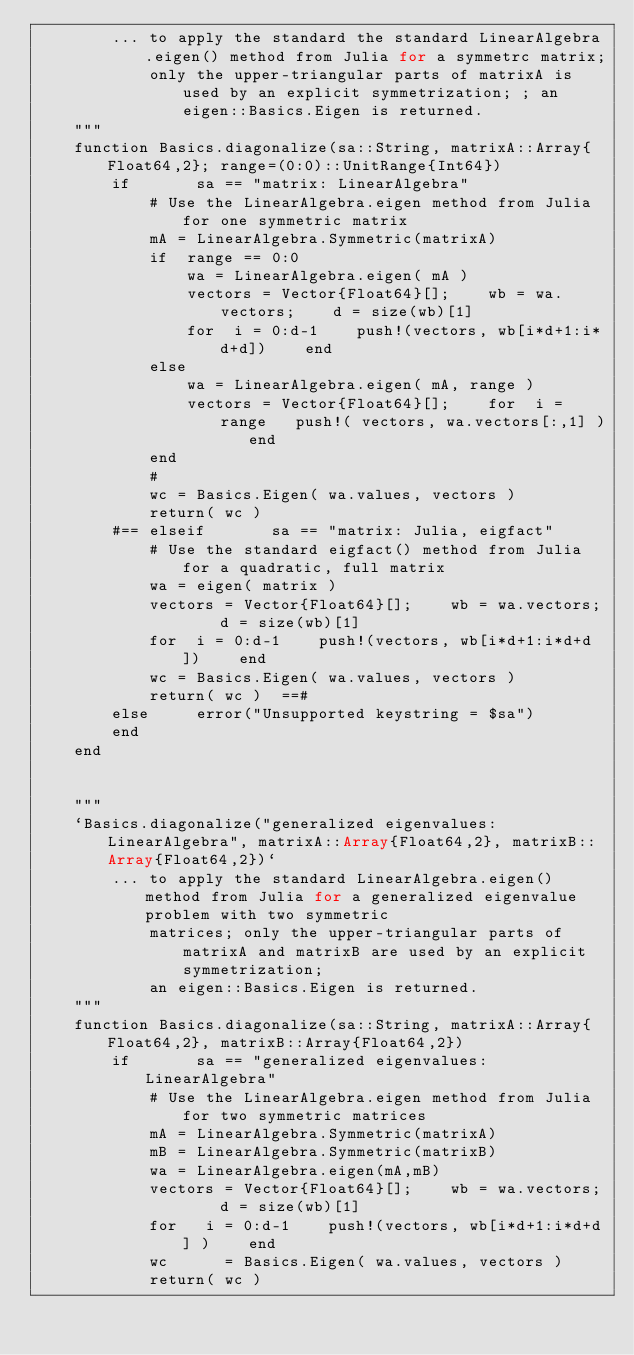<code> <loc_0><loc_0><loc_500><loc_500><_Julia_>        ... to apply the standard the standard LinearAlgebra.eigen() method from Julia for a symmetrc matrix; 
            only the upper-triangular parts of matrixA is used by an explicit symmetrization; ; an eigen::Basics.Eigen is returned.
    """
    function Basics.diagonalize(sa::String, matrixA::Array{Float64,2}; range=(0:0)::UnitRange{Int64})
        if       sa == "matrix: LinearAlgebra" 
            # Use the LinearAlgebra.eigen method from Julia for one symmetric matrix  
            mA = LinearAlgebra.Symmetric(matrixA)
            if  range == 0:0    
                wa = LinearAlgebra.eigen( mA )
                vectors = Vector{Float64}[];    wb = wa.vectors;    d = size(wb)[1]
                for  i = 0:d-1    push!(vectors, wb[i*d+1:i*d+d])    end
            else                
                wa = LinearAlgebra.eigen( mA, range )
                vectors = Vector{Float64}[];    for  i = range   push!( vectors, wa.vectors[:,1] )   end
            end
            #
            wc = Basics.Eigen( wa.values, vectors )
            return( wc )
        #== elseif       sa == "matrix: Julia, eigfact" 
            # Use the standard eigfact() method from Julia for a quadratic, full matrix   
            wa = eigen( matrix )
            vectors = Vector{Float64}[];    wb = wa.vectors;    d = size(wb)[1]
            for  i = 0:d-1    push!(vectors, wb[i*d+1:i*d+d])    end
            wc = Basics.Eigen( wa.values, vectors )
            return( wc )  ==#
        else     error("Unsupported keystring = $sa")
        end
    end


    """
    `Basics.diagonalize("generalized eigenvalues: LinearAlgebra", matrixA::Array{Float64,2}, matrixB::Array{Float64,2})`  
        ... to apply the standard LinearAlgebra.eigen() method from Julia for a generalized eigenvalue problem with two symmetric
            matrices; only the upper-triangular parts of matrixA and matrixB are used by an explicit symmetrization; 
            an eigen::Basics.Eigen is returned.
    """
    function Basics.diagonalize(sa::String, matrixA::Array{Float64,2}, matrixB::Array{Float64,2})
        if       sa == "generalized eigenvalues: LinearAlgebra" 
            # Use the LinearAlgebra.eigen method from Julia for two symmetric matrices   
            mA = LinearAlgebra.Symmetric(matrixA)
            mB = LinearAlgebra.Symmetric(matrixB)
            wa = LinearAlgebra.eigen(mA,mB)
            vectors = Vector{Float64}[];    wb = wa.vectors;    d = size(wb)[1]
            for   i = 0:d-1    push!(vectors, wb[i*d+1:i*d+d] )    end
            wc      = Basics.Eigen( wa.values, vectors )
            return( wc )</code> 